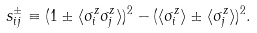Convert formula to latex. <formula><loc_0><loc_0><loc_500><loc_500>s _ { i j } ^ { \pm } \equiv ( 1 \pm \langle \sigma _ { i } ^ { z } \sigma _ { j } ^ { z } \rangle ) ^ { 2 } - ( \langle \sigma _ { i } ^ { z } \rangle \pm \langle \sigma _ { j } ^ { z } \rangle ) ^ { 2 } .</formula> 